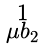<formula> <loc_0><loc_0><loc_500><loc_500>\begin{smallmatrix} 1 \\ \mu b _ { 2 } \end{smallmatrix}</formula> 